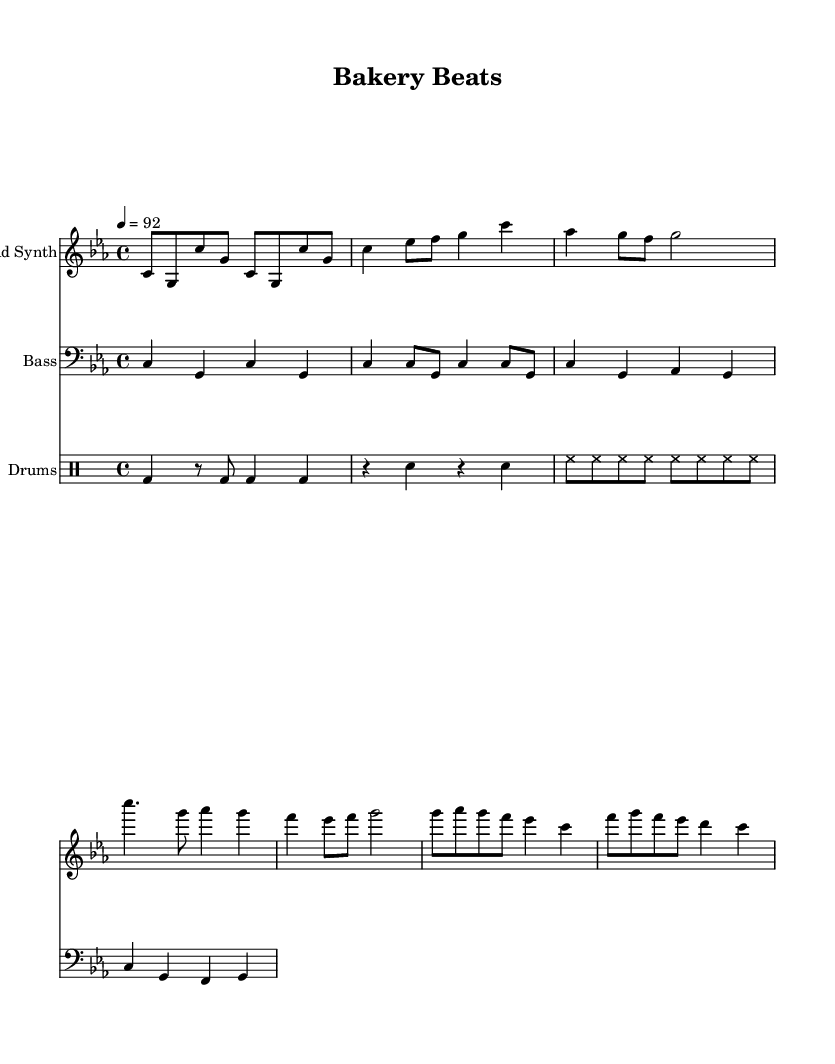What is the key signature of this music? The key signature is indicated at the beginning of the staff, showing three flats, which means the piece is in C minor.
Answer: C minor What is the time signature of this music? The time signature is also indicated at the beginning, showing a 4 over 4, which means there are four beats in a measure and the quarter note gets one beat.
Answer: 4/4 What is the tempo marking for this music? The tempo marking is found below the clef and indicates that the piece should be played at a speed of 92 beats per minute.
Answer: 92 How many measures are in the verse section? By counting the measures in the "Verse" section of the lead synth part, there are 4 measures in total.
Answer: 4 What are the main themes of the lyrics? The lyrics suggest a strong focus on fresh baked goods and local flavors, which ties into the overall theme of celebrating culinary culture.
Answer: Culinary culture Which instrument plays the bass line? The "Bass" staff indicates that the bass line is explicitly played by a staff labeled "Bass."
Answer: Bass What type of musical form is reflected in the structure of the piece? The structure shows a typical verse-chorus format, where the verse presents the main themes and the chorus is a repeated refrain that emphasizes the key messages of joy and celebration of local food.
Answer: Verse-chorus 